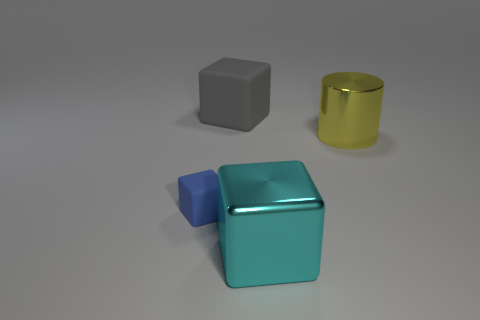Are there fewer small matte things right of the tiny thing than large cyan balls?
Ensure brevity in your answer.  No. There is a big gray object that is the same shape as the tiny object; what is it made of?
Offer a terse response. Rubber. There is a big thing that is both behind the cyan shiny block and on the left side of the shiny cylinder; what shape is it?
Make the answer very short. Cube. There is a thing that is made of the same material as the big gray cube; what shape is it?
Offer a terse response. Cube. There is a large thing that is in front of the blue cube; what material is it?
Your answer should be compact. Metal. There is a metal thing that is behind the cyan metallic thing; is it the same size as the thing behind the big cylinder?
Give a very brief answer. Yes. The shiny cube has what color?
Offer a terse response. Cyan. Does the large thing on the left side of the big cyan shiny cube have the same shape as the yellow shiny object?
Provide a succinct answer. No. What is the small block made of?
Your answer should be very brief. Rubber. What is the shape of the shiny object that is the same size as the metal cube?
Give a very brief answer. Cylinder. 